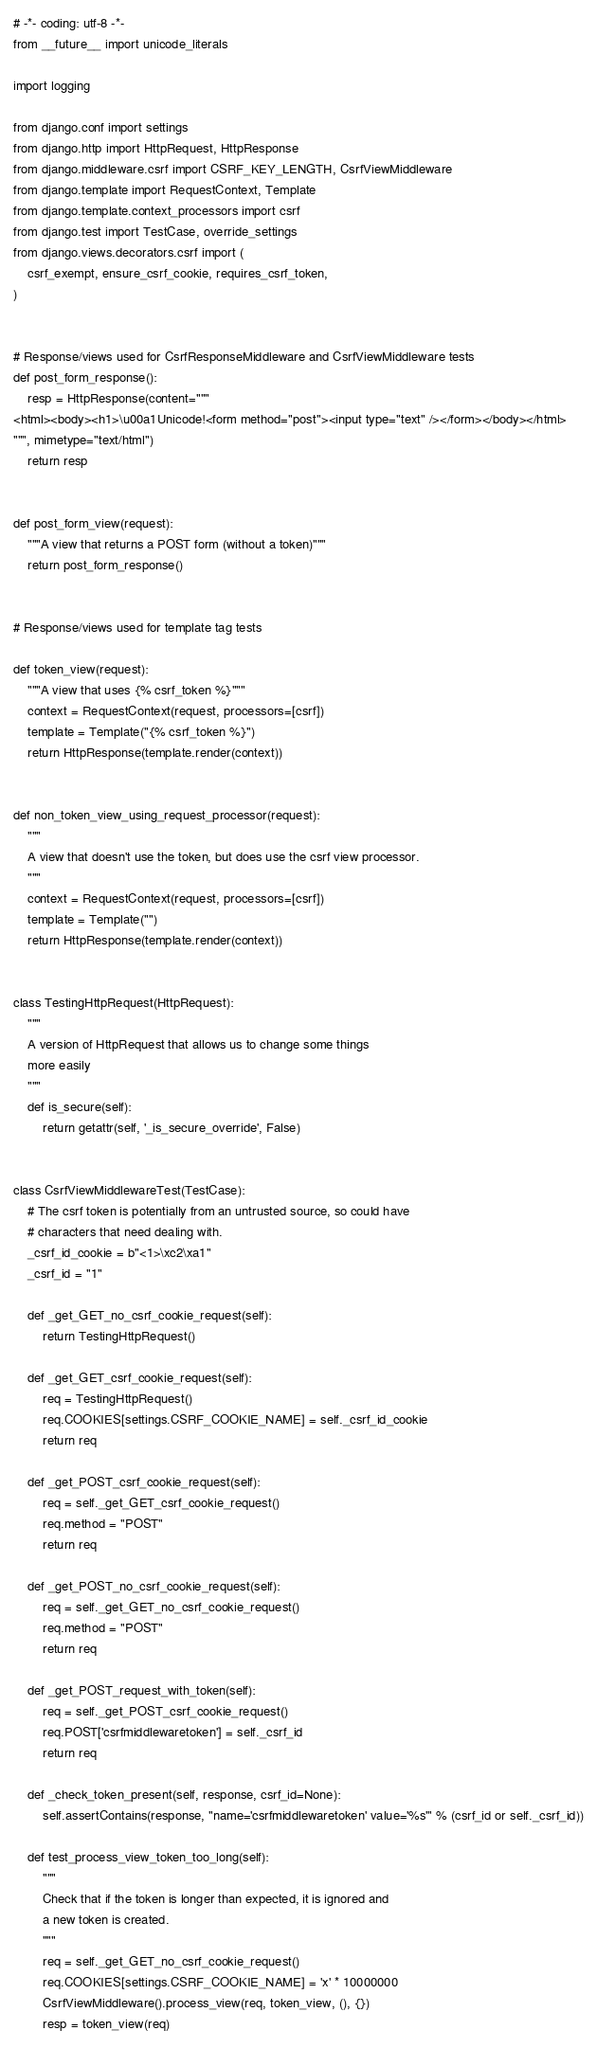Convert code to text. <code><loc_0><loc_0><loc_500><loc_500><_Python_># -*- coding: utf-8 -*-
from __future__ import unicode_literals

import logging

from django.conf import settings
from django.http import HttpRequest, HttpResponse
from django.middleware.csrf import CSRF_KEY_LENGTH, CsrfViewMiddleware
from django.template import RequestContext, Template
from django.template.context_processors import csrf
from django.test import TestCase, override_settings
from django.views.decorators.csrf import (
    csrf_exempt, ensure_csrf_cookie, requires_csrf_token,
)


# Response/views used for CsrfResponseMiddleware and CsrfViewMiddleware tests
def post_form_response():
    resp = HttpResponse(content="""
<html><body><h1>\u00a1Unicode!<form method="post"><input type="text" /></form></body></html>
""", mimetype="text/html")
    return resp


def post_form_view(request):
    """A view that returns a POST form (without a token)"""
    return post_form_response()


# Response/views used for template tag tests

def token_view(request):
    """A view that uses {% csrf_token %}"""
    context = RequestContext(request, processors=[csrf])
    template = Template("{% csrf_token %}")
    return HttpResponse(template.render(context))


def non_token_view_using_request_processor(request):
    """
    A view that doesn't use the token, but does use the csrf view processor.
    """
    context = RequestContext(request, processors=[csrf])
    template = Template("")
    return HttpResponse(template.render(context))


class TestingHttpRequest(HttpRequest):
    """
    A version of HttpRequest that allows us to change some things
    more easily
    """
    def is_secure(self):
        return getattr(self, '_is_secure_override', False)


class CsrfViewMiddlewareTest(TestCase):
    # The csrf token is potentially from an untrusted source, so could have
    # characters that need dealing with.
    _csrf_id_cookie = b"<1>\xc2\xa1"
    _csrf_id = "1"

    def _get_GET_no_csrf_cookie_request(self):
        return TestingHttpRequest()

    def _get_GET_csrf_cookie_request(self):
        req = TestingHttpRequest()
        req.COOKIES[settings.CSRF_COOKIE_NAME] = self._csrf_id_cookie
        return req

    def _get_POST_csrf_cookie_request(self):
        req = self._get_GET_csrf_cookie_request()
        req.method = "POST"
        return req

    def _get_POST_no_csrf_cookie_request(self):
        req = self._get_GET_no_csrf_cookie_request()
        req.method = "POST"
        return req

    def _get_POST_request_with_token(self):
        req = self._get_POST_csrf_cookie_request()
        req.POST['csrfmiddlewaretoken'] = self._csrf_id
        return req

    def _check_token_present(self, response, csrf_id=None):
        self.assertContains(response, "name='csrfmiddlewaretoken' value='%s'" % (csrf_id or self._csrf_id))

    def test_process_view_token_too_long(self):
        """
        Check that if the token is longer than expected, it is ignored and
        a new token is created.
        """
        req = self._get_GET_no_csrf_cookie_request()
        req.COOKIES[settings.CSRF_COOKIE_NAME] = 'x' * 10000000
        CsrfViewMiddleware().process_view(req, token_view, (), {})
        resp = token_view(req)</code> 